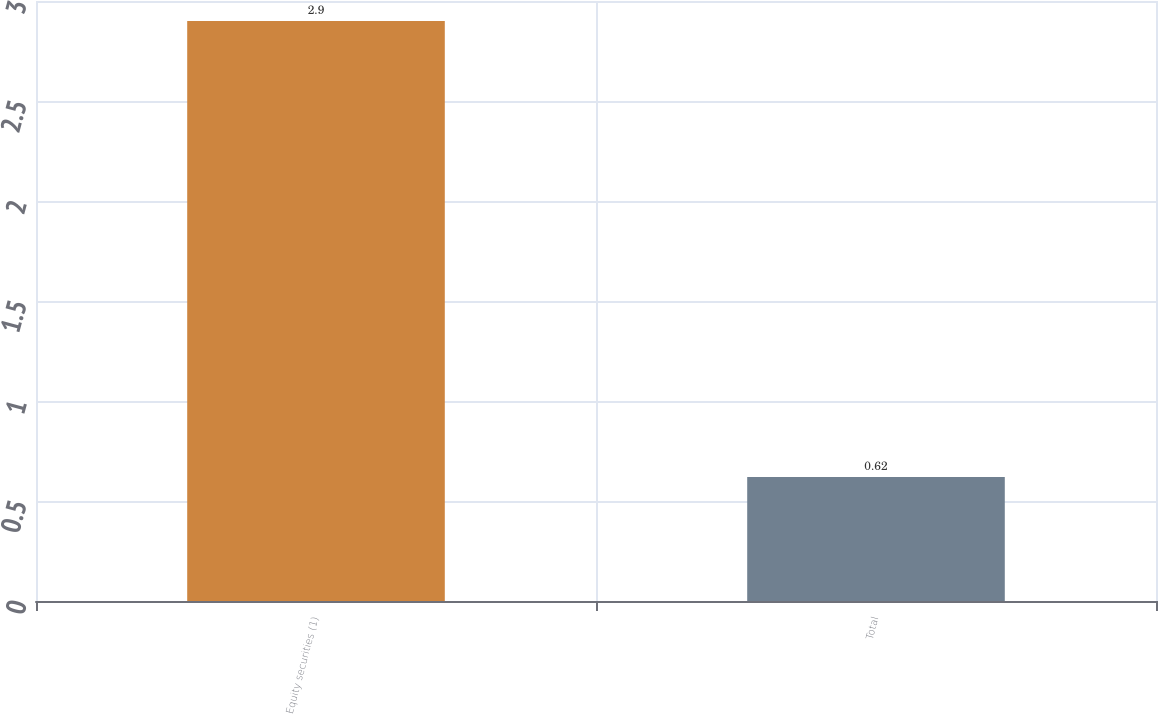Convert chart. <chart><loc_0><loc_0><loc_500><loc_500><bar_chart><fcel>Equity securities (1)<fcel>Total<nl><fcel>2.9<fcel>0.62<nl></chart> 